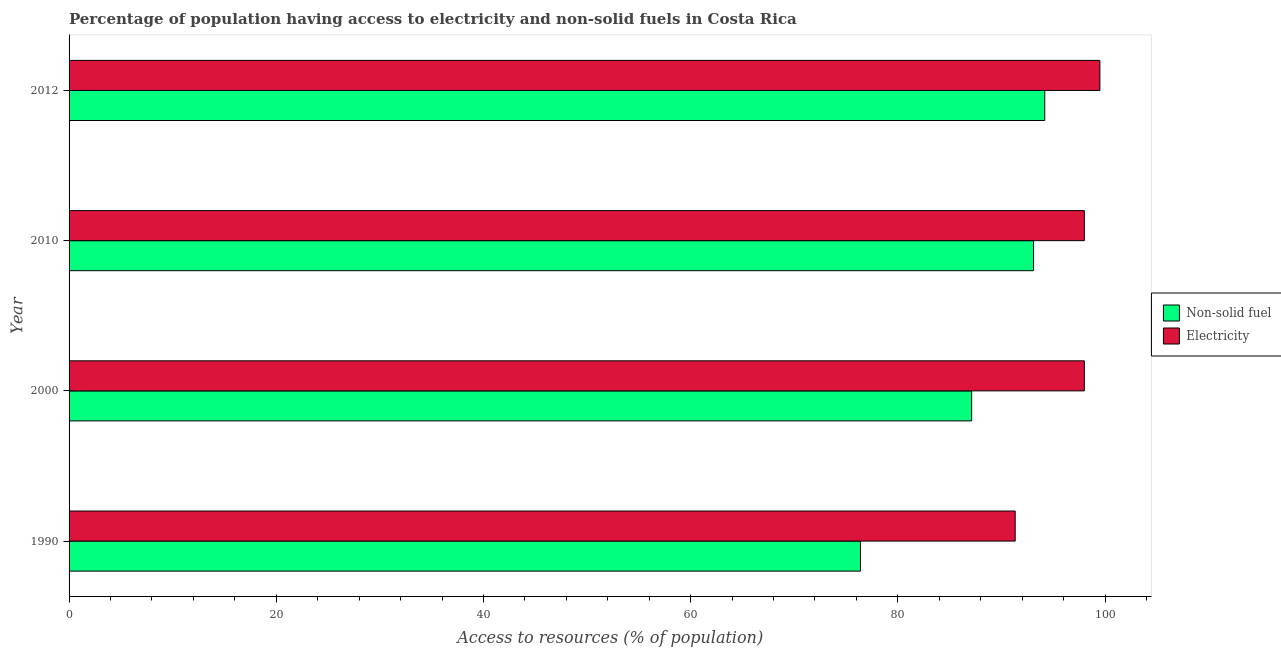How many different coloured bars are there?
Offer a very short reply. 2. How many groups of bars are there?
Provide a succinct answer. 4. Are the number of bars per tick equal to the number of legend labels?
Offer a terse response. Yes. Are the number of bars on each tick of the Y-axis equal?
Make the answer very short. Yes. How many bars are there on the 1st tick from the bottom?
Your response must be concise. 2. In how many cases, is the number of bars for a given year not equal to the number of legend labels?
Your response must be concise. 0. What is the percentage of population having access to non-solid fuel in 2000?
Your response must be concise. 87.12. Across all years, what is the maximum percentage of population having access to non-solid fuel?
Provide a succinct answer. 94.18. Across all years, what is the minimum percentage of population having access to non-solid fuel?
Make the answer very short. 76.39. In which year was the percentage of population having access to non-solid fuel minimum?
Give a very brief answer. 1990. What is the total percentage of population having access to electricity in the graph?
Ensure brevity in your answer.  386.83. What is the difference between the percentage of population having access to electricity in 1990 and that in 2010?
Provide a short and direct response. -6.67. What is the difference between the percentage of population having access to non-solid fuel in 2000 and the percentage of population having access to electricity in 1990?
Provide a succinct answer. -4.2. What is the average percentage of population having access to non-solid fuel per year?
Ensure brevity in your answer.  87.7. In the year 2012, what is the difference between the percentage of population having access to electricity and percentage of population having access to non-solid fuel?
Make the answer very short. 5.32. In how many years, is the percentage of population having access to electricity greater than 4 %?
Ensure brevity in your answer.  4. What is the ratio of the percentage of population having access to electricity in 1990 to that in 2012?
Give a very brief answer. 0.92. What is the difference between the highest and the lowest percentage of population having access to electricity?
Keep it short and to the point. 8.17. What does the 2nd bar from the top in 2000 represents?
Your answer should be compact. Non-solid fuel. What does the 1st bar from the bottom in 1990 represents?
Provide a short and direct response. Non-solid fuel. How many bars are there?
Keep it short and to the point. 8. Are all the bars in the graph horizontal?
Give a very brief answer. Yes. Are the values on the major ticks of X-axis written in scientific E-notation?
Ensure brevity in your answer.  No. Does the graph contain any zero values?
Make the answer very short. No. How are the legend labels stacked?
Ensure brevity in your answer.  Vertical. What is the title of the graph?
Give a very brief answer. Percentage of population having access to electricity and non-solid fuels in Costa Rica. What is the label or title of the X-axis?
Your answer should be very brief. Access to resources (% of population). What is the Access to resources (% of population) in Non-solid fuel in 1990?
Offer a terse response. 76.39. What is the Access to resources (% of population) in Electricity in 1990?
Your answer should be compact. 91.33. What is the Access to resources (% of population) in Non-solid fuel in 2000?
Provide a succinct answer. 87.12. What is the Access to resources (% of population) in Electricity in 2000?
Offer a very short reply. 98. What is the Access to resources (% of population) in Non-solid fuel in 2010?
Give a very brief answer. 93.1. What is the Access to resources (% of population) in Electricity in 2010?
Ensure brevity in your answer.  98. What is the Access to resources (% of population) of Non-solid fuel in 2012?
Your answer should be compact. 94.18. What is the Access to resources (% of population) in Electricity in 2012?
Make the answer very short. 99.5. Across all years, what is the maximum Access to resources (% of population) in Non-solid fuel?
Your answer should be very brief. 94.18. Across all years, what is the maximum Access to resources (% of population) in Electricity?
Keep it short and to the point. 99.5. Across all years, what is the minimum Access to resources (% of population) of Non-solid fuel?
Ensure brevity in your answer.  76.39. Across all years, what is the minimum Access to resources (% of population) in Electricity?
Your answer should be very brief. 91.33. What is the total Access to resources (% of population) in Non-solid fuel in the graph?
Provide a succinct answer. 350.79. What is the total Access to resources (% of population) in Electricity in the graph?
Give a very brief answer. 386.83. What is the difference between the Access to resources (% of population) of Non-solid fuel in 1990 and that in 2000?
Make the answer very short. -10.73. What is the difference between the Access to resources (% of population) in Electricity in 1990 and that in 2000?
Your answer should be compact. -6.67. What is the difference between the Access to resources (% of population) of Non-solid fuel in 1990 and that in 2010?
Keep it short and to the point. -16.71. What is the difference between the Access to resources (% of population) of Electricity in 1990 and that in 2010?
Offer a terse response. -6.67. What is the difference between the Access to resources (% of population) of Non-solid fuel in 1990 and that in 2012?
Make the answer very short. -17.79. What is the difference between the Access to resources (% of population) of Electricity in 1990 and that in 2012?
Keep it short and to the point. -8.17. What is the difference between the Access to resources (% of population) in Non-solid fuel in 2000 and that in 2010?
Give a very brief answer. -5.98. What is the difference between the Access to resources (% of population) in Non-solid fuel in 2000 and that in 2012?
Offer a terse response. -7.06. What is the difference between the Access to resources (% of population) in Non-solid fuel in 2010 and that in 2012?
Your response must be concise. -1.08. What is the difference between the Access to resources (% of population) of Non-solid fuel in 1990 and the Access to resources (% of population) of Electricity in 2000?
Provide a succinct answer. -21.61. What is the difference between the Access to resources (% of population) in Non-solid fuel in 1990 and the Access to resources (% of population) in Electricity in 2010?
Offer a terse response. -21.61. What is the difference between the Access to resources (% of population) of Non-solid fuel in 1990 and the Access to resources (% of population) of Electricity in 2012?
Make the answer very short. -23.11. What is the difference between the Access to resources (% of population) of Non-solid fuel in 2000 and the Access to resources (% of population) of Electricity in 2010?
Your answer should be compact. -10.88. What is the difference between the Access to resources (% of population) of Non-solid fuel in 2000 and the Access to resources (% of population) of Electricity in 2012?
Provide a short and direct response. -12.38. What is the difference between the Access to resources (% of population) in Non-solid fuel in 2010 and the Access to resources (% of population) in Electricity in 2012?
Offer a very short reply. -6.4. What is the average Access to resources (% of population) of Non-solid fuel per year?
Ensure brevity in your answer.  87.7. What is the average Access to resources (% of population) of Electricity per year?
Your response must be concise. 96.71. In the year 1990, what is the difference between the Access to resources (% of population) in Non-solid fuel and Access to resources (% of population) in Electricity?
Ensure brevity in your answer.  -14.94. In the year 2000, what is the difference between the Access to resources (% of population) of Non-solid fuel and Access to resources (% of population) of Electricity?
Offer a very short reply. -10.88. In the year 2010, what is the difference between the Access to resources (% of population) of Non-solid fuel and Access to resources (% of population) of Electricity?
Provide a short and direct response. -4.9. In the year 2012, what is the difference between the Access to resources (% of population) in Non-solid fuel and Access to resources (% of population) in Electricity?
Make the answer very short. -5.32. What is the ratio of the Access to resources (% of population) of Non-solid fuel in 1990 to that in 2000?
Provide a succinct answer. 0.88. What is the ratio of the Access to resources (% of population) of Electricity in 1990 to that in 2000?
Your response must be concise. 0.93. What is the ratio of the Access to resources (% of population) of Non-solid fuel in 1990 to that in 2010?
Offer a terse response. 0.82. What is the ratio of the Access to resources (% of population) of Electricity in 1990 to that in 2010?
Give a very brief answer. 0.93. What is the ratio of the Access to resources (% of population) in Non-solid fuel in 1990 to that in 2012?
Your answer should be compact. 0.81. What is the ratio of the Access to resources (% of population) in Electricity in 1990 to that in 2012?
Your answer should be compact. 0.92. What is the ratio of the Access to resources (% of population) in Non-solid fuel in 2000 to that in 2010?
Offer a very short reply. 0.94. What is the ratio of the Access to resources (% of population) in Electricity in 2000 to that in 2010?
Your answer should be very brief. 1. What is the ratio of the Access to resources (% of population) of Non-solid fuel in 2000 to that in 2012?
Give a very brief answer. 0.93. What is the ratio of the Access to resources (% of population) of Electricity in 2000 to that in 2012?
Provide a short and direct response. 0.98. What is the ratio of the Access to resources (% of population) of Electricity in 2010 to that in 2012?
Keep it short and to the point. 0.98. What is the difference between the highest and the second highest Access to resources (% of population) in Non-solid fuel?
Offer a terse response. 1.08. What is the difference between the highest and the second highest Access to resources (% of population) of Electricity?
Provide a succinct answer. 1.5. What is the difference between the highest and the lowest Access to resources (% of population) in Non-solid fuel?
Give a very brief answer. 17.79. What is the difference between the highest and the lowest Access to resources (% of population) of Electricity?
Provide a succinct answer. 8.17. 